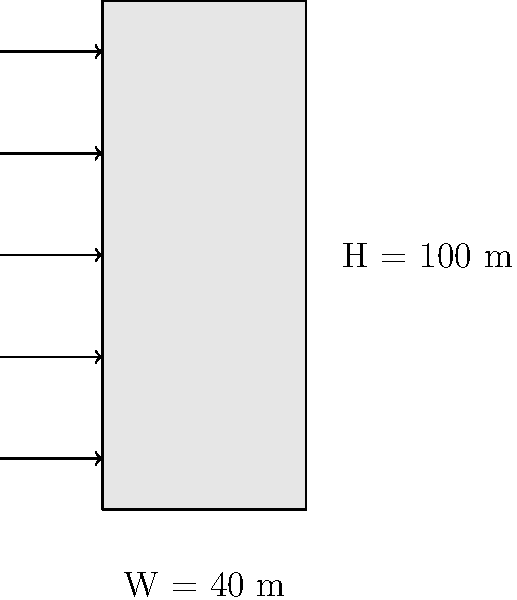As a parent who meticulously plans meals, you understand the importance of precise measurements. Apply this attention to detail to calculate the wind load on a rectangular building facade. The building is 100 meters tall and 40 meters wide, located in an area with a basic wind speed of 45 m/s. Assume a gust effect factor of 0.85 and a pressure coefficient of 0.8. What is the total wind load on the facade in kilonewtons (kN)?

Given:
- Air density (ρ) = 1.225 kg/m³
- Wind load equation: $F = q_z G C_p A$
- Velocity pressure: $q_z = 0.613 K_z K_{zt} K_d V^2$ (in N/m²)
- Assume exposure coefficient ($K_z$) = 1.0, topographic factor ($K_{zt}$) = 1.0, and wind directionality factor ($K_d$) = 0.85 Let's approach this step-by-step:

1) First, calculate the velocity pressure ($q_z$):
   $q_z = 0.613 K_z K_{zt} K_d V^2$
   $q_z = 0.613 \cdot 1.0 \cdot 1.0 \cdot 0.85 \cdot 45^2$
   $q_z = 1055.97$ N/m²

2) Calculate the facade area (A):
   $A = H \cdot W = 100 \text{ m} \cdot 40 \text{ m} = 4000$ m²

3) Now, use the wind load equation:
   $F = q_z G C_p A$
   Where:
   $q_z = 1055.97$ N/m² (calculated)
   $G = 0.85$ (given gust effect factor)
   $C_p = 0.8$ (given pressure coefficient)
   $A = 4000$ m² (calculated)

4) Plug in the values:
   $F = 1055.97 \cdot 0.85 \cdot 0.8 \cdot 4000$
   $F = 2875427.36$ N

5) Convert to kilonewtons:
   $F = 2875427.36 \text{ N} \cdot \frac{1 \text{ kN}}{1000 \text{ N}} = 2875.43$ kN

Therefore, the total wind load on the facade is approximately 2875.43 kN.
Answer: 2875.43 kN 